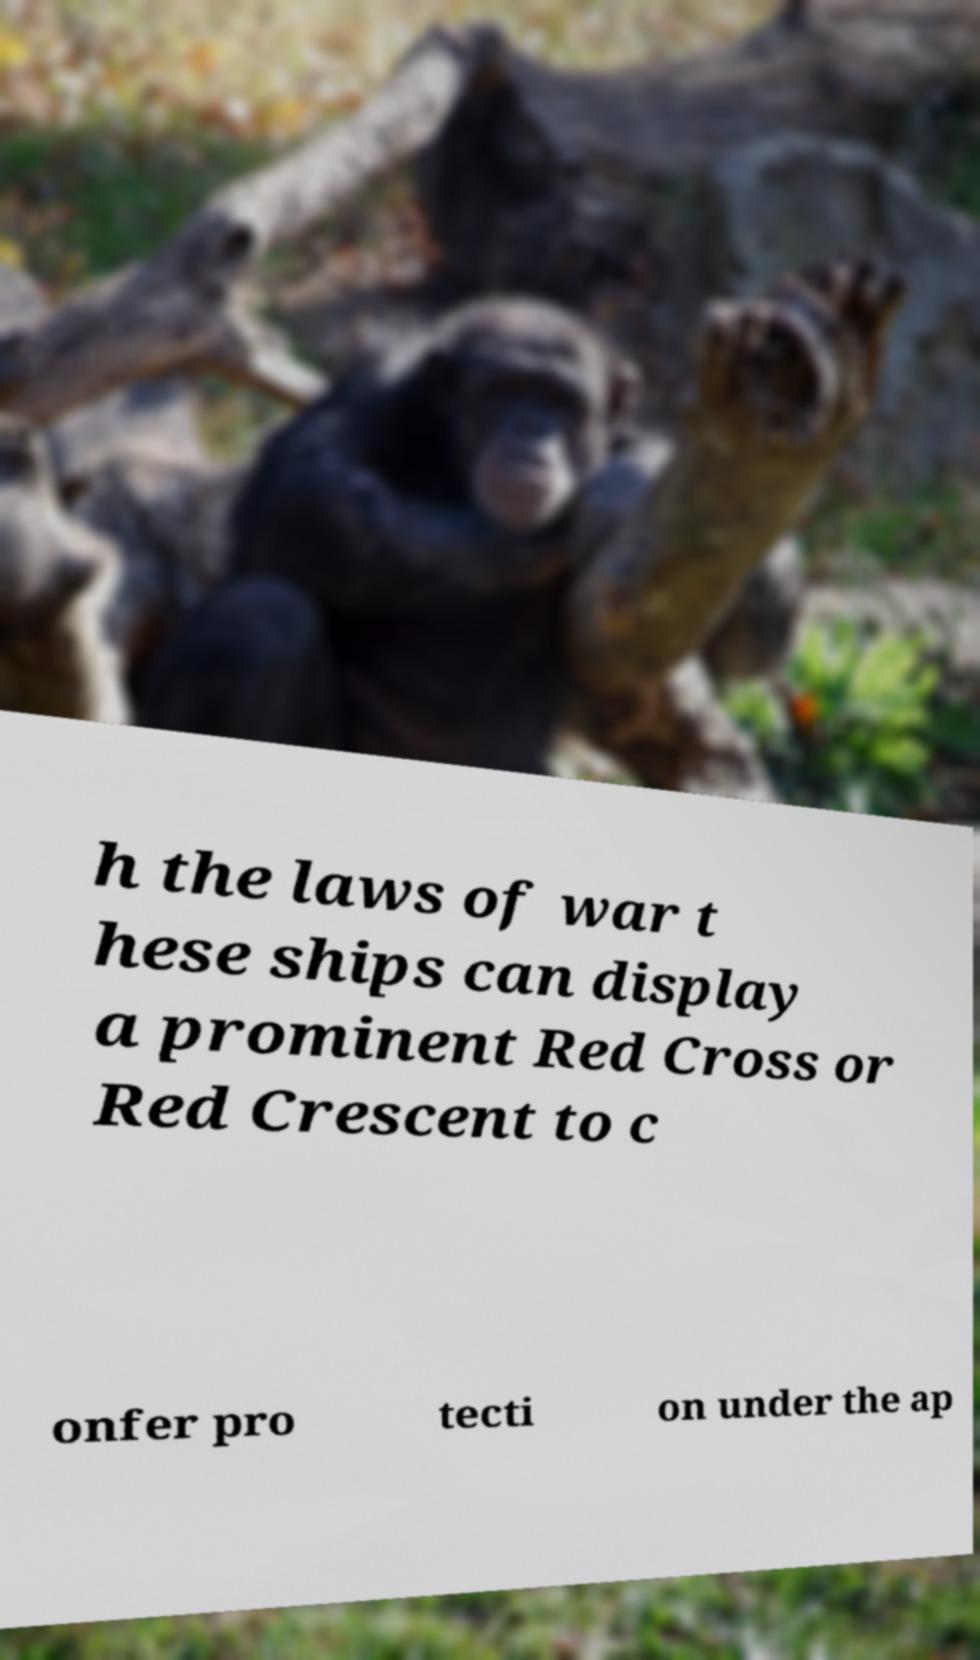I need the written content from this picture converted into text. Can you do that? h the laws of war t hese ships can display a prominent Red Cross or Red Crescent to c onfer pro tecti on under the ap 